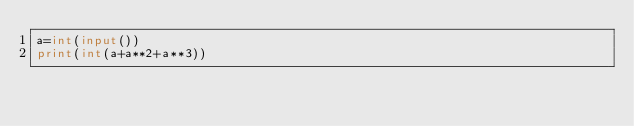Convert code to text. <code><loc_0><loc_0><loc_500><loc_500><_Python_>a=int(input())
print(int(a+a**2+a**3))</code> 